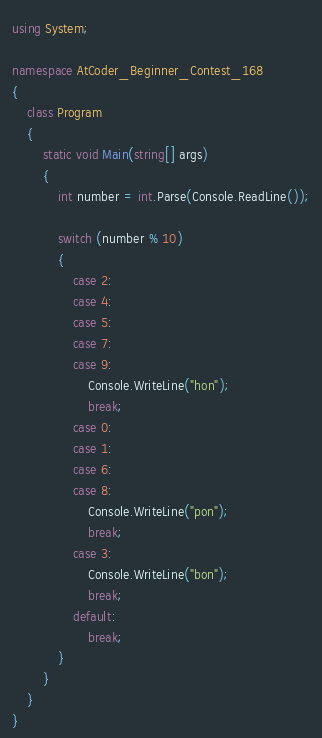Convert code to text. <code><loc_0><loc_0><loc_500><loc_500><_C#_>using System;

namespace AtCoder_Beginner_Contest_168
{
    class Program
    {
        static void Main(string[] args)
        {
            int number = int.Parse(Console.ReadLine());

            switch (number % 10)
            {
                case 2:
                case 4:
                case 5:
                case 7:
                case 9:
                    Console.WriteLine("hon");
                    break;
                case 0:
                case 1:
                case 6:
                case 8:
                    Console.WriteLine("pon");
                    break;
                case 3:
                    Console.WriteLine("bon");
                    break;
                default:
                    break;
            }
        }
    }
}
</code> 